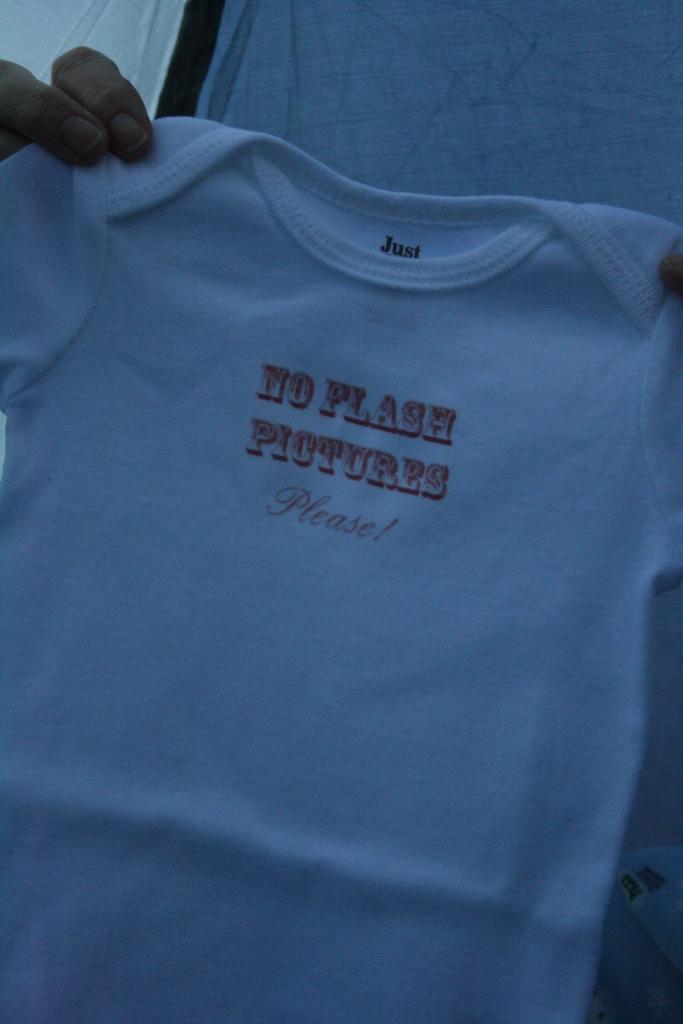No flash what?
Provide a succinct answer. Pictures. What is printed on the outfit?
Give a very brief answer. No flash pictures please!. 